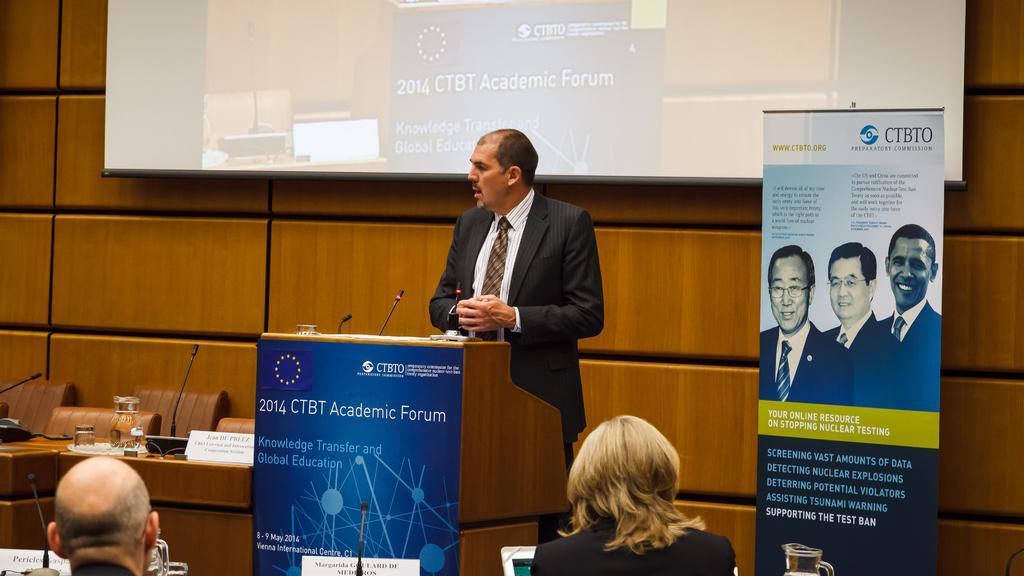Could you give a brief overview of what you see in this image? In this image there is a person standing, in front of the person there is a table. On the table there are two mics, in front of this person there are another two persons sitting, in front of them there is a monitor and mic. On the left side of the image there are two chairs and table. On the table there are few mice and some other object. On the right side there is a banner. In the background there is a screen and a wall. 